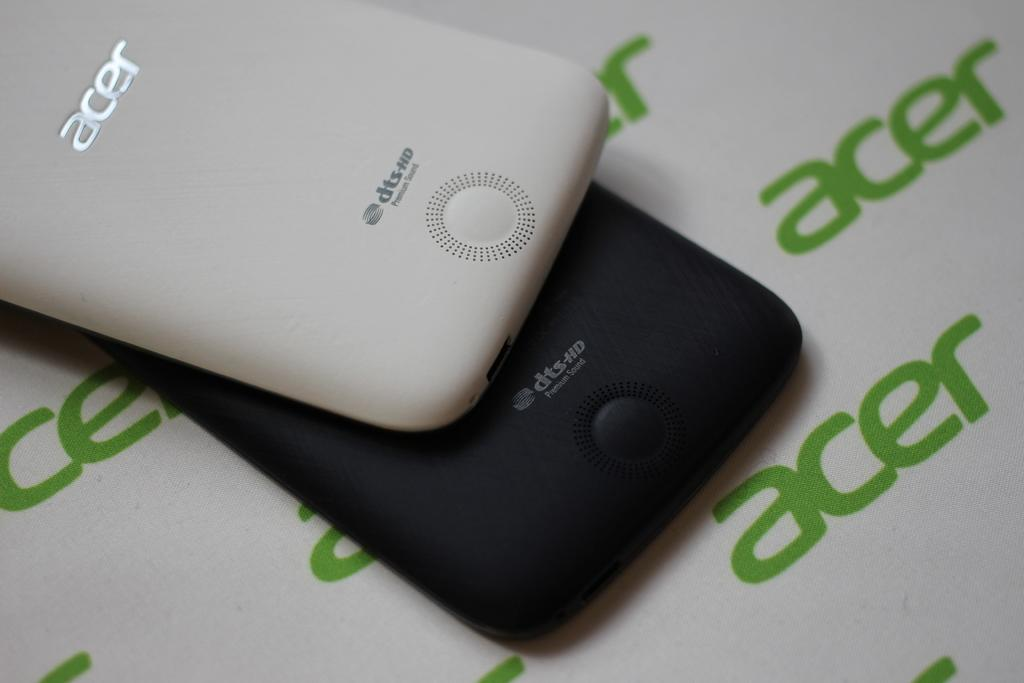<image>
Provide a brief description of the given image. Two dts HD phones, black and white, sit on a background with the word "acer" in green on it. 